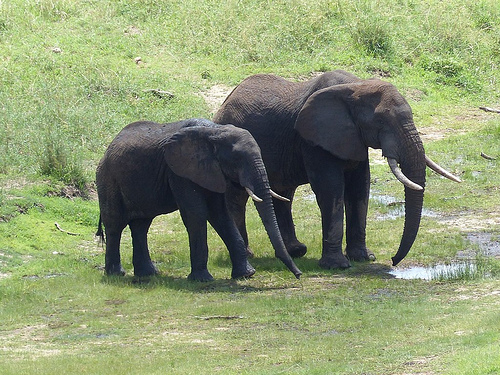Are there any elephants or bears? Yes, there are elephants visible in the image. 